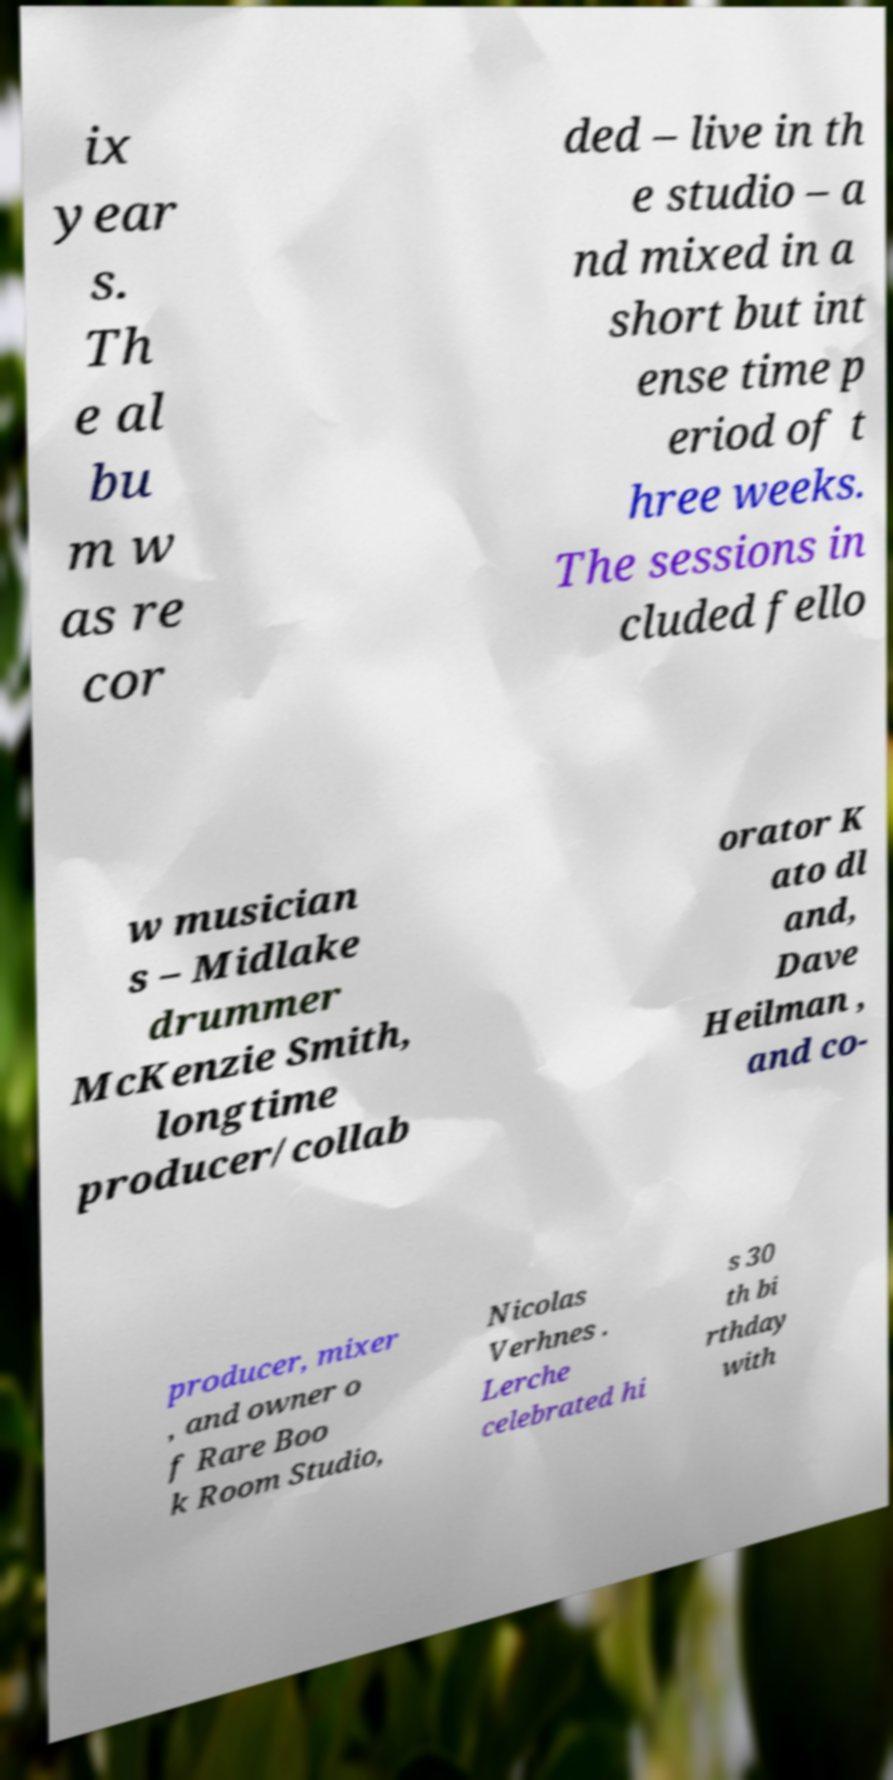Could you assist in decoding the text presented in this image and type it out clearly? ix year s. Th e al bu m w as re cor ded – live in th e studio – a nd mixed in a short but int ense time p eriod of t hree weeks. The sessions in cluded fello w musician s – Midlake drummer McKenzie Smith, longtime producer/collab orator K ato dl and, Dave Heilman , and co- producer, mixer , and owner o f Rare Boo k Room Studio, Nicolas Verhnes . Lerche celebrated hi s 30 th bi rthday with 